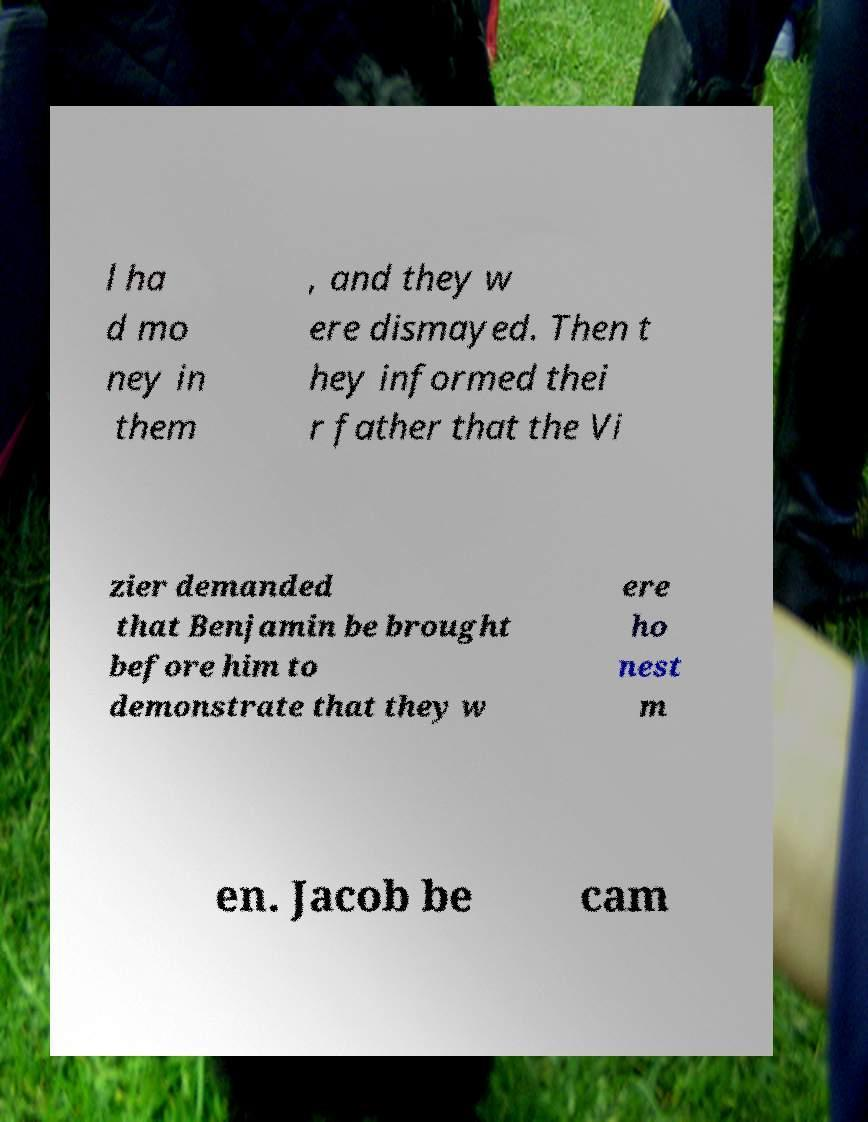There's text embedded in this image that I need extracted. Can you transcribe it verbatim? l ha d mo ney in them , and they w ere dismayed. Then t hey informed thei r father that the Vi zier demanded that Benjamin be brought before him to demonstrate that they w ere ho nest m en. Jacob be cam 